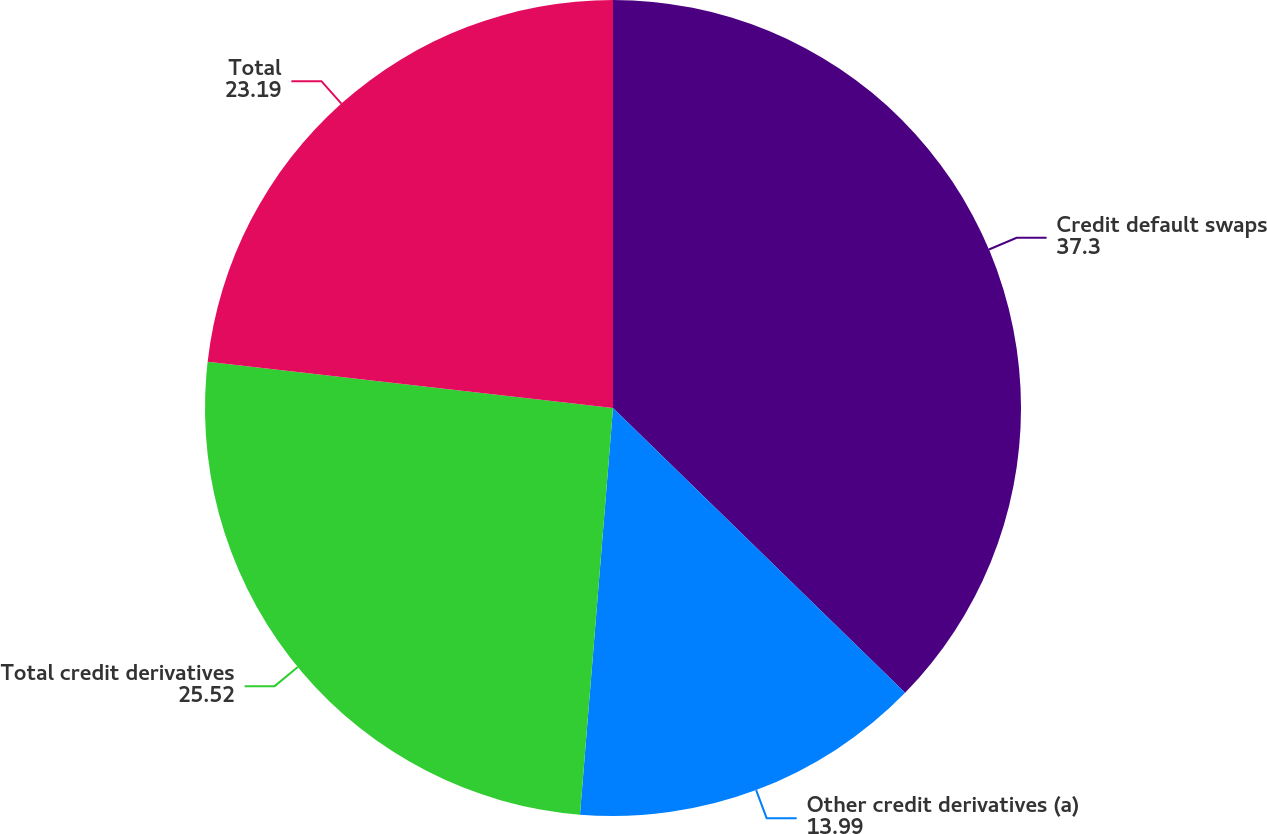<chart> <loc_0><loc_0><loc_500><loc_500><pie_chart><fcel>Credit default swaps<fcel>Other credit derivatives (a)<fcel>Total credit derivatives<fcel>Total<nl><fcel>37.3%<fcel>13.99%<fcel>25.52%<fcel>23.19%<nl></chart> 